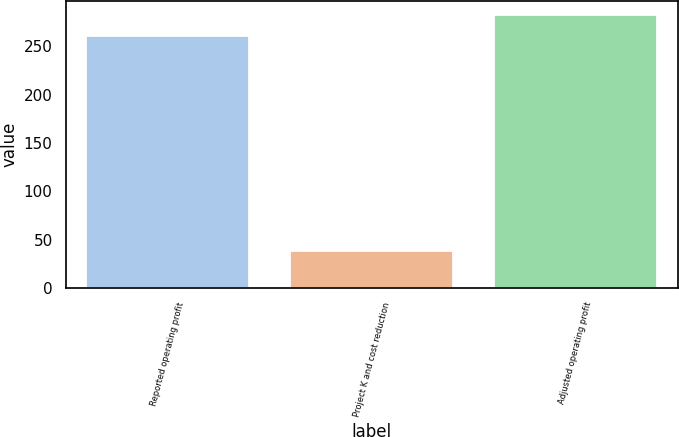Convert chart to OTSL. <chart><loc_0><loc_0><loc_500><loc_500><bar_chart><fcel>Reported operating profit<fcel>Project K and cost reduction<fcel>Adjusted operating profit<nl><fcel>260<fcel>38<fcel>282.7<nl></chart> 